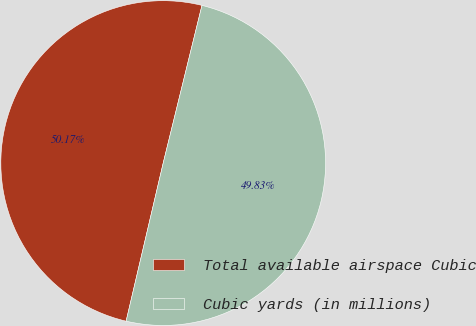Convert chart. <chart><loc_0><loc_0><loc_500><loc_500><pie_chart><fcel>Total available airspace Cubic<fcel>Cubic yards (in millions)<nl><fcel>50.17%<fcel>49.83%<nl></chart> 